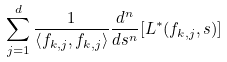<formula> <loc_0><loc_0><loc_500><loc_500>\sum _ { j = 1 } ^ { d } \frac { 1 } { \left < f _ { k , j } , f _ { k , j } \right > } \frac { d ^ { n } } { d s ^ { n } } [ L ^ { * } ( f _ { k , j } , s ) ]</formula> 